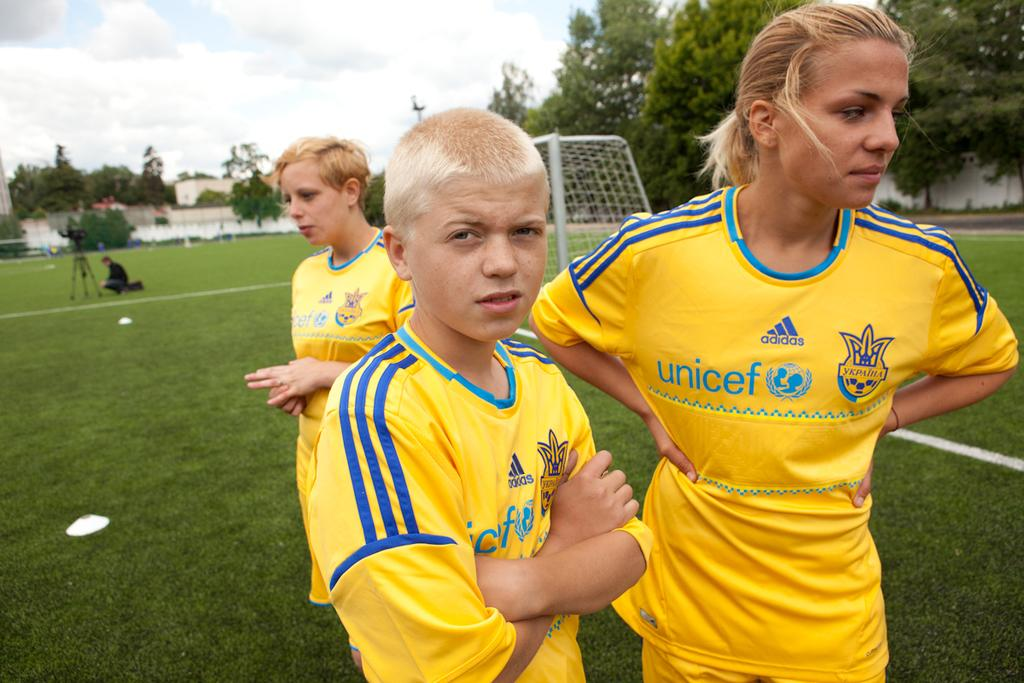<image>
Describe the image concisely. Some people on a football field wearing shirts with Unicef written on them 